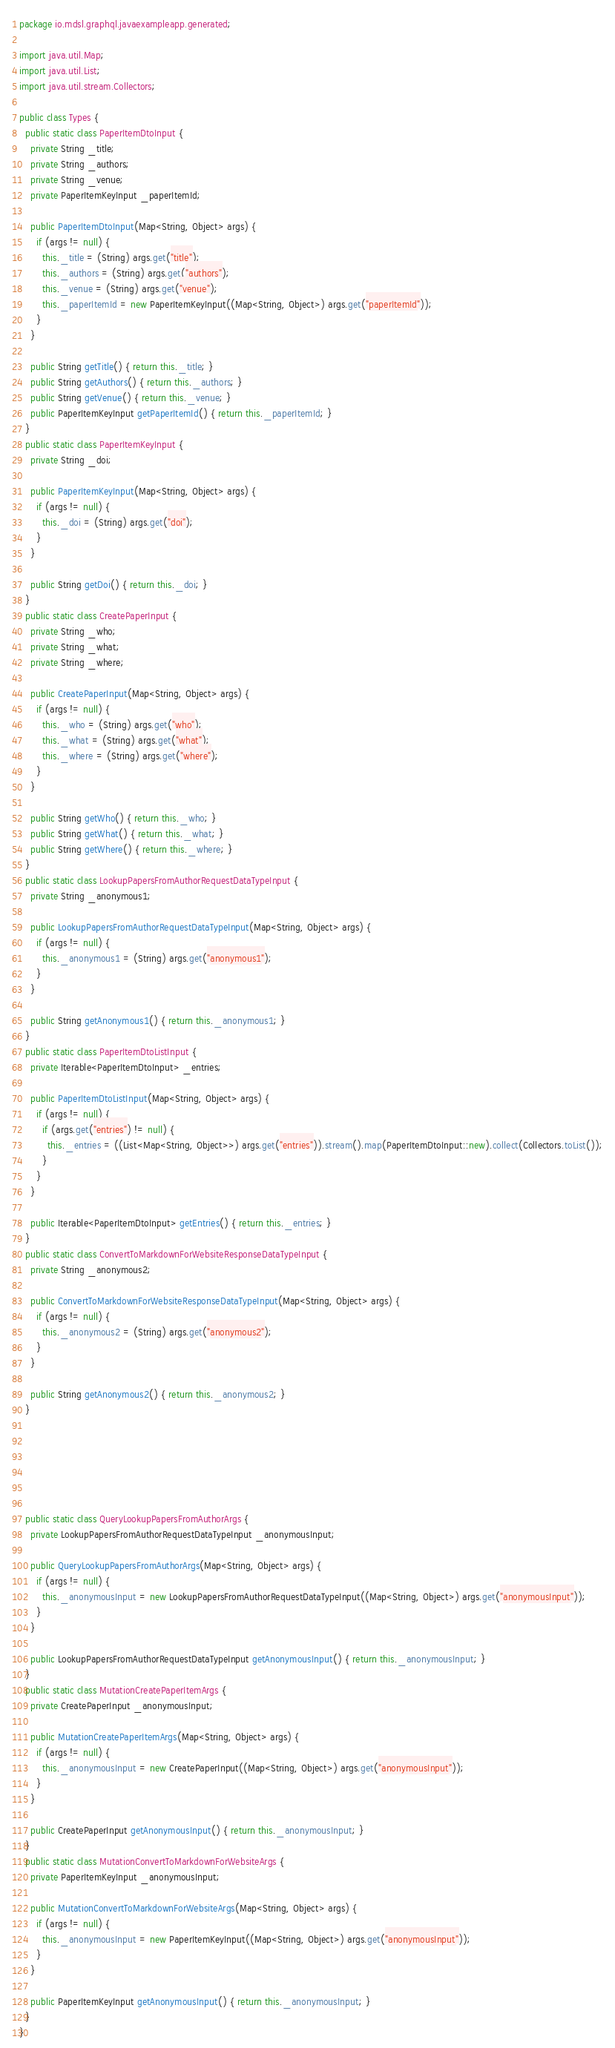Convert code to text. <code><loc_0><loc_0><loc_500><loc_500><_Java_>package io.mdsl.graphql.javaexampleapp.generated;

import java.util.Map;
import java.util.List;
import java.util.stream.Collectors;

public class Types {
  public static class PaperItemDtoInput {
    private String _title;
    private String _authors;
    private String _venue;
    private PaperItemKeyInput _paperItemId;
  
    public PaperItemDtoInput(Map<String, Object> args) {
      if (args != null) {
        this._title = (String) args.get("title");
        this._authors = (String) args.get("authors");
        this._venue = (String) args.get("venue");
        this._paperItemId = new PaperItemKeyInput((Map<String, Object>) args.get("paperItemId"));
      }
    }
  
    public String getTitle() { return this._title; }
    public String getAuthors() { return this._authors; }
    public String getVenue() { return this._venue; }
    public PaperItemKeyInput getPaperItemId() { return this._paperItemId; }
  }
  public static class PaperItemKeyInput {
    private String _doi;
  
    public PaperItemKeyInput(Map<String, Object> args) {
      if (args != null) {
        this._doi = (String) args.get("doi");
      }
    }
  
    public String getDoi() { return this._doi; }
  }
  public static class CreatePaperInput {
    private String _who;
    private String _what;
    private String _where;
  
    public CreatePaperInput(Map<String, Object> args) {
      if (args != null) {
        this._who = (String) args.get("who");
        this._what = (String) args.get("what");
        this._where = (String) args.get("where");
      }
    }
  
    public String getWho() { return this._who; }
    public String getWhat() { return this._what; }
    public String getWhere() { return this._where; }
  }
  public static class LookupPapersFromAuthorRequestDataTypeInput {
    private String _anonymous1;
  
    public LookupPapersFromAuthorRequestDataTypeInput(Map<String, Object> args) {
      if (args != null) {
        this._anonymous1 = (String) args.get("anonymous1");
      }
    }
  
    public String getAnonymous1() { return this._anonymous1; }
  }
  public static class PaperItemDtoListInput {
    private Iterable<PaperItemDtoInput> _entries;
  
    public PaperItemDtoListInput(Map<String, Object> args) {
      if (args != null) {
        if (args.get("entries") != null) {
          this._entries = ((List<Map<String, Object>>) args.get("entries")).stream().map(PaperItemDtoInput::new).collect(Collectors.toList());
        }
      }
    }
  
    public Iterable<PaperItemDtoInput> getEntries() { return this._entries; }
  }
  public static class ConvertToMarkdownForWebsiteResponseDataTypeInput {
    private String _anonymous2;
  
    public ConvertToMarkdownForWebsiteResponseDataTypeInput(Map<String, Object> args) {
      if (args != null) {
        this._anonymous2 = (String) args.get("anonymous2");
      }
    }
  
    public String getAnonymous2() { return this._anonymous2; }
  }
  
  
  
  
  
  
  public static class QueryLookupPapersFromAuthorArgs {
    private LookupPapersFromAuthorRequestDataTypeInput _anonymousInput;
  
    public QueryLookupPapersFromAuthorArgs(Map<String, Object> args) {
      if (args != null) {
        this._anonymousInput = new LookupPapersFromAuthorRequestDataTypeInput((Map<String, Object>) args.get("anonymousInput"));
      }
    }
  
    public LookupPapersFromAuthorRequestDataTypeInput getAnonymousInput() { return this._anonymousInput; }
  }
  public static class MutationCreatePaperItemArgs {
    private CreatePaperInput _anonymousInput;
  
    public MutationCreatePaperItemArgs(Map<String, Object> args) {
      if (args != null) {
        this._anonymousInput = new CreatePaperInput((Map<String, Object>) args.get("anonymousInput"));
      }
    }
  
    public CreatePaperInput getAnonymousInput() { return this._anonymousInput; }
  }
  public static class MutationConvertToMarkdownForWebsiteArgs {
    private PaperItemKeyInput _anonymousInput;
  
    public MutationConvertToMarkdownForWebsiteArgs(Map<String, Object> args) {
      if (args != null) {
        this._anonymousInput = new PaperItemKeyInput((Map<String, Object>) args.get("anonymousInput"));
      }
    }
  
    public PaperItemKeyInput getAnonymousInput() { return this._anonymousInput; }
  }
}
</code> 